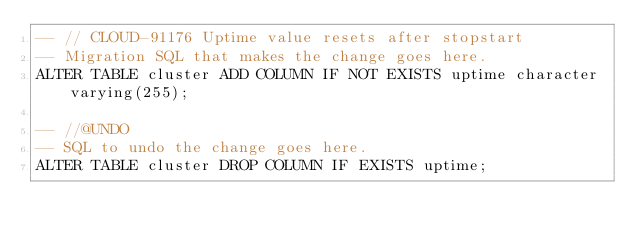Convert code to text. <code><loc_0><loc_0><loc_500><loc_500><_SQL_>-- // CLOUD-91176 Uptime value resets after stopstart
-- Migration SQL that makes the change goes here.
ALTER TABLE cluster ADD COLUMN IF NOT EXISTS uptime character varying(255);

-- //@UNDO
-- SQL to undo the change goes here.
ALTER TABLE cluster DROP COLUMN IF EXISTS uptime;


</code> 